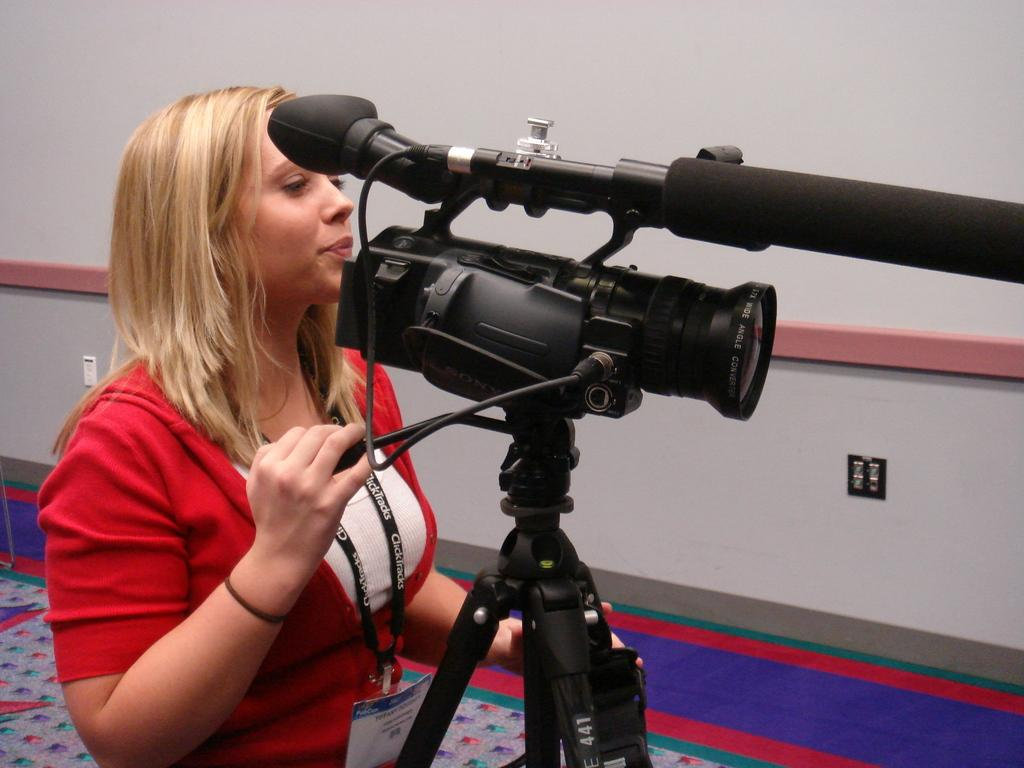Who is the main subject in the image? There is a woman in the image. What is the woman doing in the image? The woman is handling a video camera. What can be seen in the background of the image? There is a wall in the background of the image. What is present at the bottom of the image? There is a mat at the bottom of the image. What is the woman wearing that identifies her? The woman is wearing an identity card. What type of polish is the woman applying to her teeth in the image? There is no indication in the image that the woman is applying any polish to her teeth. 